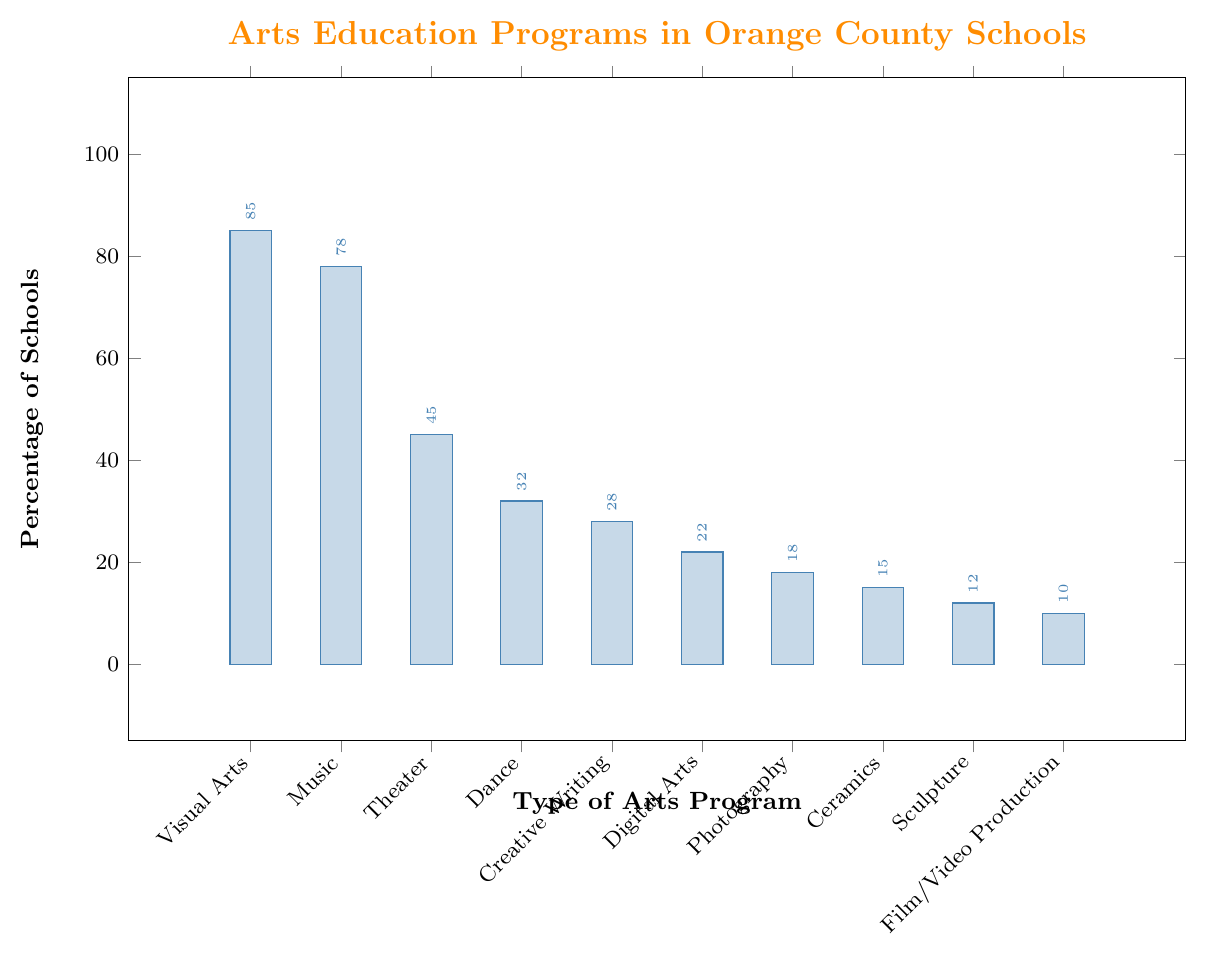Which type of arts program is offered by the highest percentage of schools in Orange County? To identify the arts program offered by the highest percentage of schools, look at the bar with the greatest height in the chart. The "Visual Arts" bar is the tallest, indicating that 85% of schools offer this program.
Answer: Visual Arts Which two arts programs have the smallest percentage of schools offering them, and what are their percentages? To find the two arts programs with the smallest percentages, identify the two shortest bars on the chart. "Film/Video Production" has 10% and "Sculpture" has 12%.
Answer: Film/Video Production, Sculpture How much higher is the percentage of schools offering "Visual Arts" compared to "Digital Arts"? To determine the difference, subtract the percentage of schools offering Digital Arts (22%) from the percentage offering Visual Arts (85%). Calculation: 85% - 22% = 63%.
Answer: 63% What is the combined percentage of schools that offer "Theater" and "Dance" programs? Add the percentage of schools offering Theater (45%) to those offering Dance (32%). Calculation: 45% + 32% = 77%.
Answer: 77% Which arts program has a near 50% offering rate among schools, and is it greater or less than 50%? Identify the bar that is close to 50%. "Theater" has a 45% offering rate, which is less than 50%.
Answer: Theater, less than 50% What percentage of schools offer "Ceramics" programs, and how does it compare to those offering "Photography"? Look at the bars for Ceramics (15%) and Photography (18%). Compare their heights. Ceramics is 3% less than Photography.
Answer: 15%, less than Photography Rank the top three arts programs by their offering percentages. Identify the three tallest bars in the chart. They represent Visual Arts (85%), Music (78%), and Theater (45%).
Answer: Visual Arts, Music, Theater Is the percentage of schools offering "Creative Writing" less than those offering "Music"? If yes, by how much? Compare the heights of the bars for Creative Writing (28%) and Music (78%). Subtract 28% from 78%. Calculation: 78% - 28% = 50%.
Answer: Yes, by 50% Calculate the average percentage of schools offering "Digital Arts," "Photography," "Ceramics," and "Sculpture." Add their percentages and divide by the number of programs. Calculation: (22% + 18% + 15% + 12%) / 4 = 67% / 4 = 16.75%
Answer: 16.75% Between "Music" and "Creative Writing", which program is more commonly offered, and by what margin? Compare the bars for Music (78%) and Creative Writing (28%). Subtract 28% from 78%. Calculation: 78% - 28% = 50%.
Answer: Music, by 50% 